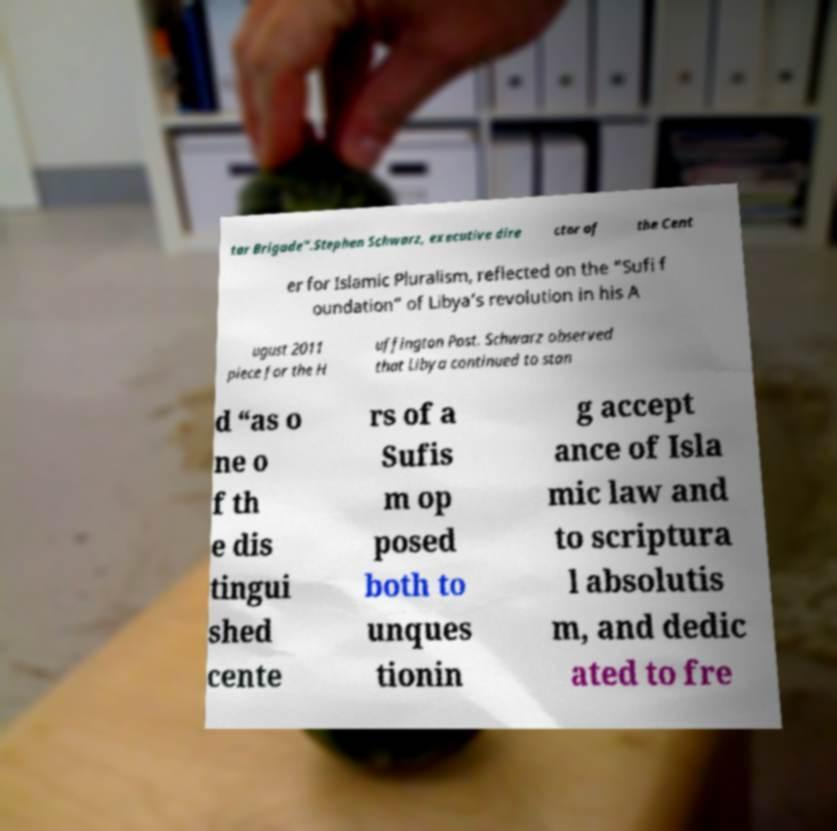For documentation purposes, I need the text within this image transcribed. Could you provide that? tar Brigade”.Stephen Schwarz, executive dire ctor of the Cent er for Islamic Pluralism, reflected on the “Sufi f oundation” of Libya’s revolution in his A ugust 2011 piece for the H uffington Post. Schwarz observed that Libya continued to stan d “as o ne o f th e dis tingui shed cente rs of a Sufis m op posed both to unques tionin g accept ance of Isla mic law and to scriptura l absolutis m, and dedic ated to fre 